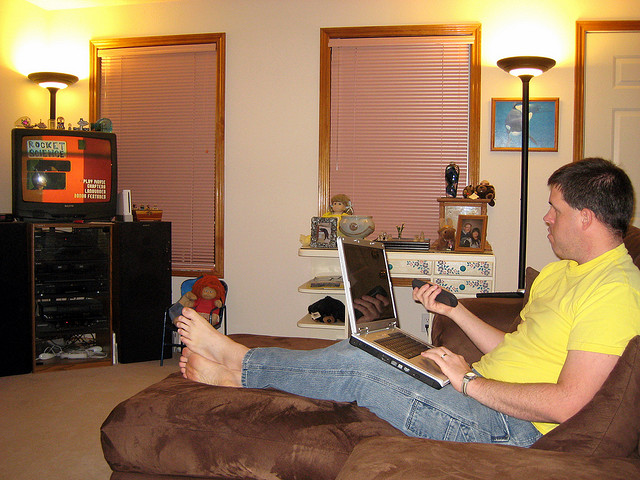What kind of items can be seen on the shelves in the room? On the shelves, there appears to be a collection of small decorative items and framed photographs which contribute to the homely atmosphere. What activities could the person be doing on the laptop? The person could be working, browsing the internet, engaging in social media, streaming videos, or even participating in a video conference. 